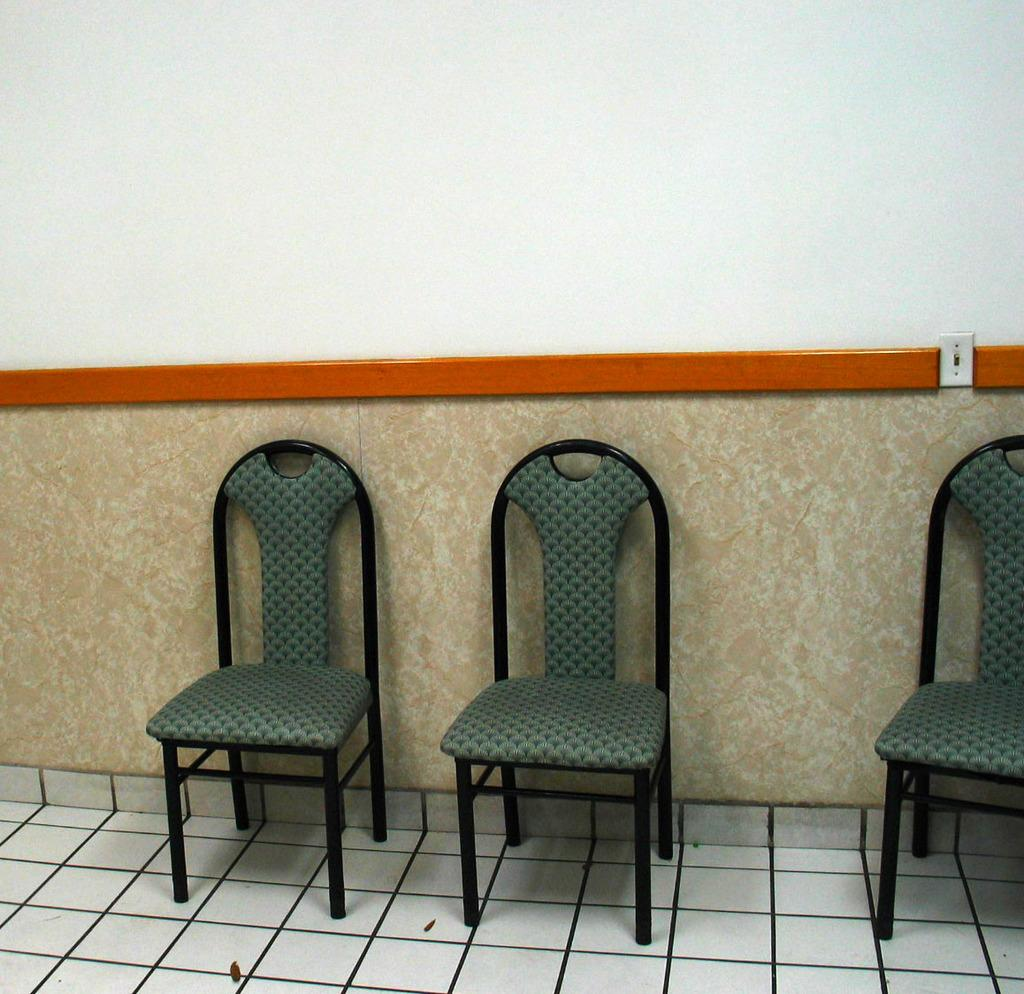What type of furniture is on the floor in the image? There are chairs on the floor in the image. What object can be seen on the floor besides the chairs? There is a marble visible on the floor in the image. What is the background of the image made up of? There is a wall visible in the image. What type of lettuce is growing on the wall in the image? There is no lettuce present in the image; it only features chairs, a marble, and a wall. What type of coach can be seen in the image? There is no coach present in the image. 